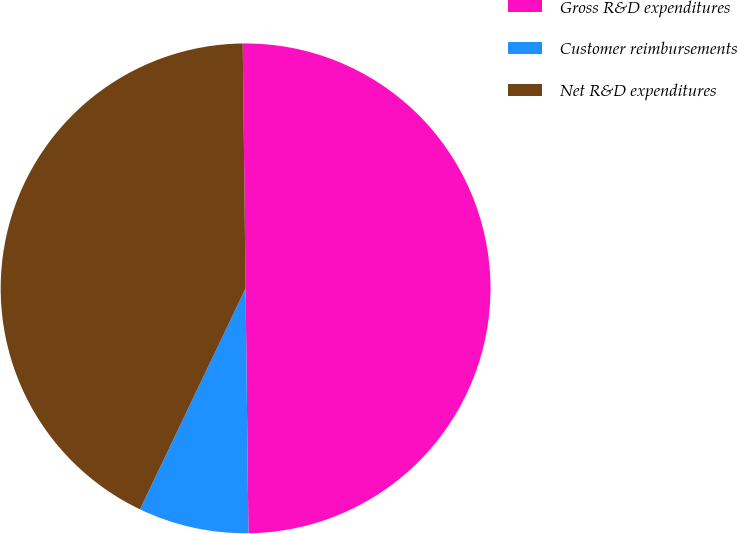<chart> <loc_0><loc_0><loc_500><loc_500><pie_chart><fcel>Gross R&D expenditures<fcel>Customer reimbursements<fcel>Net R&D expenditures<nl><fcel>50.0%<fcel>7.28%<fcel>42.72%<nl></chart> 